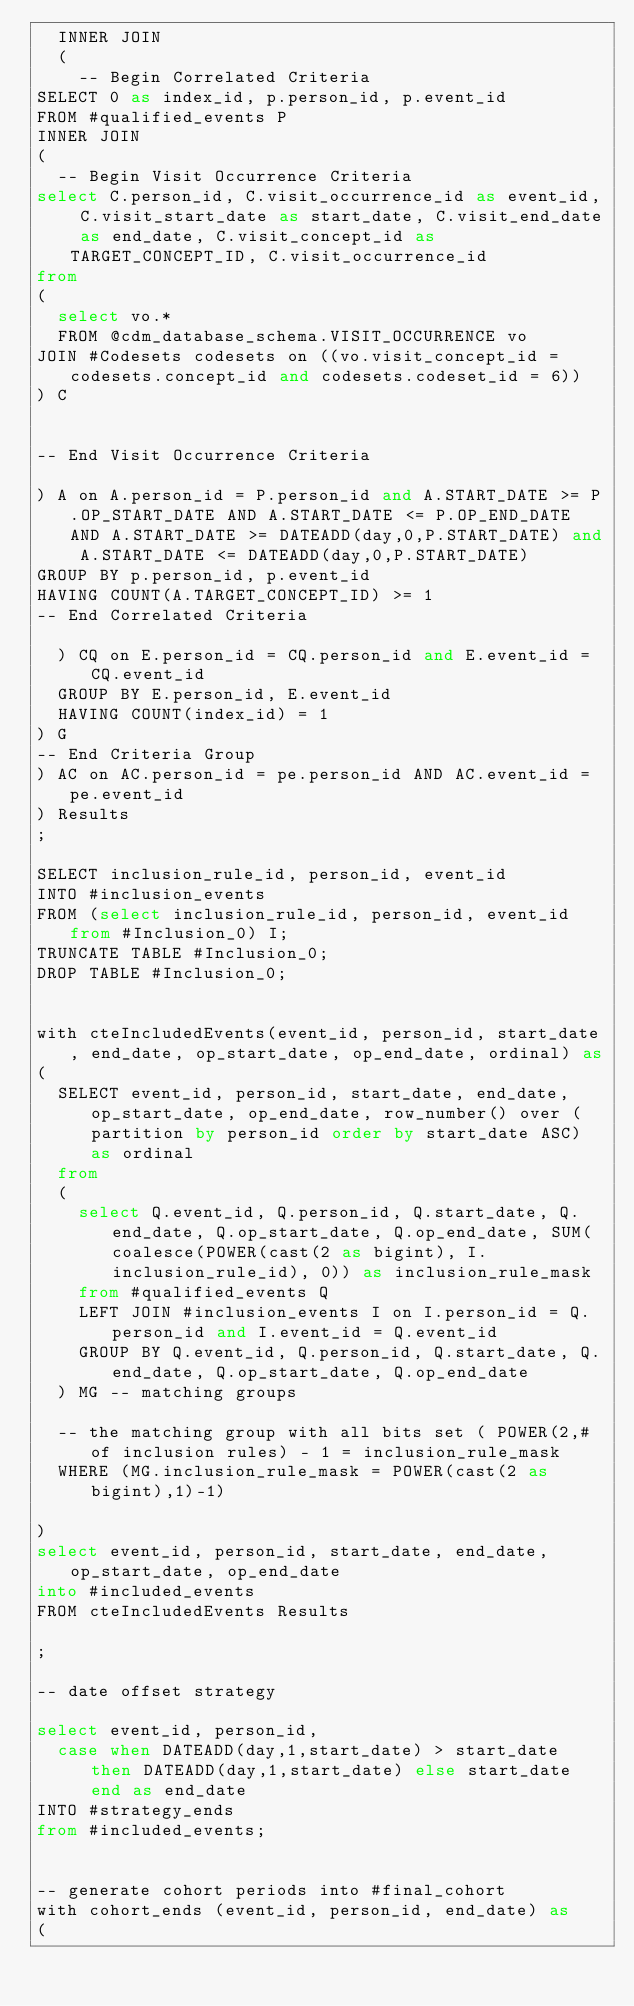<code> <loc_0><loc_0><loc_500><loc_500><_SQL_>  INNER JOIN
  (
    -- Begin Correlated Criteria
SELECT 0 as index_id, p.person_id, p.event_id
FROM #qualified_events P
INNER JOIN
(
  -- Begin Visit Occurrence Criteria
select C.person_id, C.visit_occurrence_id as event_id, C.visit_start_date as start_date, C.visit_end_date as end_date, C.visit_concept_id as TARGET_CONCEPT_ID, C.visit_occurrence_id
from 
(
  select vo.* 
  FROM @cdm_database_schema.VISIT_OCCURRENCE vo
JOIN #Codesets codesets on ((vo.visit_concept_id = codesets.concept_id and codesets.codeset_id = 6))
) C


-- End Visit Occurrence Criteria

) A on A.person_id = P.person_id and A.START_DATE >= P.OP_START_DATE AND A.START_DATE <= P.OP_END_DATE AND A.START_DATE >= DATEADD(day,0,P.START_DATE) and A.START_DATE <= DATEADD(day,0,P.START_DATE)
GROUP BY p.person_id, p.event_id
HAVING COUNT(A.TARGET_CONCEPT_ID) >= 1
-- End Correlated Criteria

  ) CQ on E.person_id = CQ.person_id and E.event_id = CQ.event_id
  GROUP BY E.person_id, E.event_id
  HAVING COUNT(index_id) = 1
) G
-- End Criteria Group
) AC on AC.person_id = pe.person_id AND AC.event_id = pe.event_id
) Results
;

SELECT inclusion_rule_id, person_id, event_id
INTO #inclusion_events
FROM (select inclusion_rule_id, person_id, event_id from #Inclusion_0) I;
TRUNCATE TABLE #Inclusion_0;
DROP TABLE #Inclusion_0;


with cteIncludedEvents(event_id, person_id, start_date, end_date, op_start_date, op_end_date, ordinal) as
(
  SELECT event_id, person_id, start_date, end_date, op_start_date, op_end_date, row_number() over (partition by person_id order by start_date ASC) as ordinal
  from
  (
    select Q.event_id, Q.person_id, Q.start_date, Q.end_date, Q.op_start_date, Q.op_end_date, SUM(coalesce(POWER(cast(2 as bigint), I.inclusion_rule_id), 0)) as inclusion_rule_mask
    from #qualified_events Q
    LEFT JOIN #inclusion_events I on I.person_id = Q.person_id and I.event_id = Q.event_id
    GROUP BY Q.event_id, Q.person_id, Q.start_date, Q.end_date, Q.op_start_date, Q.op_end_date
  ) MG -- matching groups

  -- the matching group with all bits set ( POWER(2,# of inclusion rules) - 1 = inclusion_rule_mask
  WHERE (MG.inclusion_rule_mask = POWER(cast(2 as bigint),1)-1)

)
select event_id, person_id, start_date, end_date, op_start_date, op_end_date
into #included_events
FROM cteIncludedEvents Results

;

-- date offset strategy

select event_id, person_id, 
  case when DATEADD(day,1,start_date) > start_date then DATEADD(day,1,start_date) else start_date end as end_date
INTO #strategy_ends
from #included_events;


-- generate cohort periods into #final_cohort
with cohort_ends (event_id, person_id, end_date) as
(</code> 